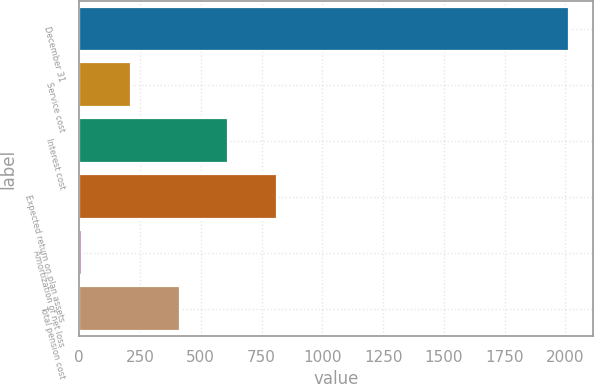Convert chart. <chart><loc_0><loc_0><loc_500><loc_500><bar_chart><fcel>December 31<fcel>Service cost<fcel>Interest cost<fcel>Expected return on plan assets<fcel>Amortization of net loss<fcel>Total pension cost<nl><fcel>2014<fcel>213.1<fcel>613.3<fcel>813.4<fcel>13<fcel>413.2<nl></chart> 